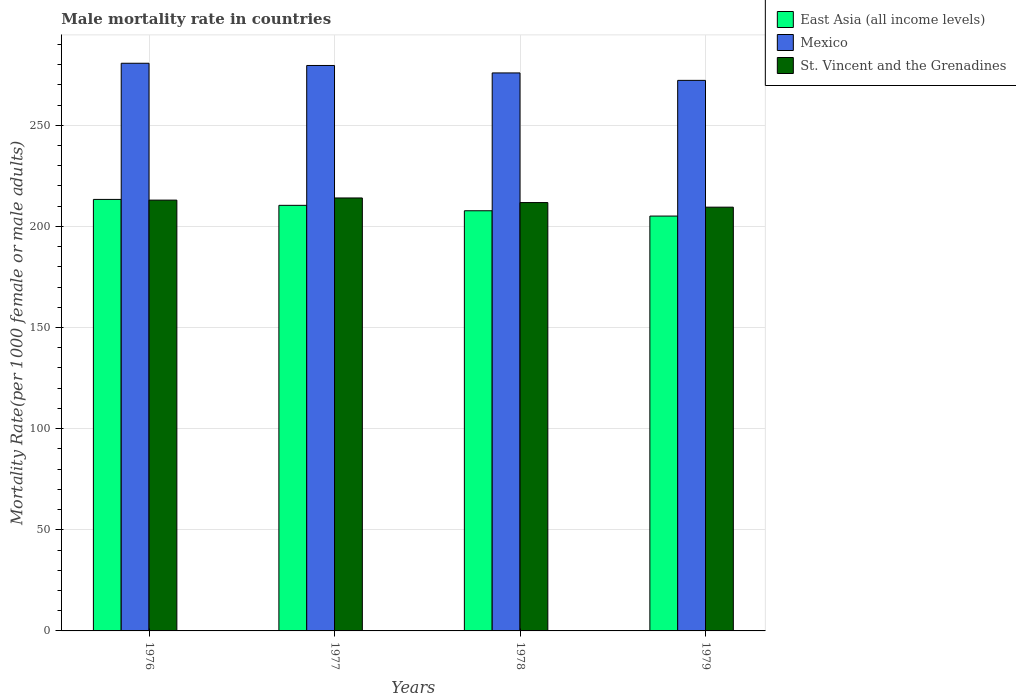How many different coloured bars are there?
Your response must be concise. 3. How many groups of bars are there?
Your answer should be very brief. 4. What is the label of the 2nd group of bars from the left?
Make the answer very short. 1977. What is the male mortality rate in St. Vincent and the Grenadines in 1976?
Ensure brevity in your answer.  212.99. Across all years, what is the maximum male mortality rate in St. Vincent and the Grenadines?
Make the answer very short. 214.05. Across all years, what is the minimum male mortality rate in East Asia (all income levels)?
Provide a short and direct response. 205.1. In which year was the male mortality rate in East Asia (all income levels) maximum?
Give a very brief answer. 1976. In which year was the male mortality rate in East Asia (all income levels) minimum?
Keep it short and to the point. 1979. What is the total male mortality rate in East Asia (all income levels) in the graph?
Provide a short and direct response. 836.56. What is the difference between the male mortality rate in St. Vincent and the Grenadines in 1977 and that in 1979?
Provide a succinct answer. 4.55. What is the difference between the male mortality rate in St. Vincent and the Grenadines in 1977 and the male mortality rate in Mexico in 1979?
Keep it short and to the point. -58.14. What is the average male mortality rate in Mexico per year?
Give a very brief answer. 277.06. In the year 1976, what is the difference between the male mortality rate in St. Vincent and the Grenadines and male mortality rate in Mexico?
Ensure brevity in your answer.  -67.66. What is the ratio of the male mortality rate in East Asia (all income levels) in 1978 to that in 1979?
Provide a short and direct response. 1.01. What is the difference between the highest and the second highest male mortality rate in St. Vincent and the Grenadines?
Offer a terse response. 1.06. What is the difference between the highest and the lowest male mortality rate in St. Vincent and the Grenadines?
Give a very brief answer. 4.55. In how many years, is the male mortality rate in St. Vincent and the Grenadines greater than the average male mortality rate in St. Vincent and the Grenadines taken over all years?
Give a very brief answer. 2. What does the 3rd bar from the right in 1978 represents?
Offer a terse response. East Asia (all income levels). How many bars are there?
Ensure brevity in your answer.  12. Are all the bars in the graph horizontal?
Your response must be concise. No. Does the graph contain any zero values?
Your answer should be very brief. No. Does the graph contain grids?
Keep it short and to the point. Yes. How are the legend labels stacked?
Offer a terse response. Vertical. What is the title of the graph?
Offer a very short reply. Male mortality rate in countries. Does "Korea (Democratic)" appear as one of the legend labels in the graph?
Your response must be concise. No. What is the label or title of the Y-axis?
Your answer should be very brief. Mortality Rate(per 1000 female or male adults). What is the Mortality Rate(per 1000 female or male adults) in East Asia (all income levels) in 1976?
Ensure brevity in your answer.  213.33. What is the Mortality Rate(per 1000 female or male adults) in Mexico in 1976?
Ensure brevity in your answer.  280.65. What is the Mortality Rate(per 1000 female or male adults) in St. Vincent and the Grenadines in 1976?
Provide a short and direct response. 212.99. What is the Mortality Rate(per 1000 female or male adults) of East Asia (all income levels) in 1977?
Offer a terse response. 210.41. What is the Mortality Rate(per 1000 female or male adults) in Mexico in 1977?
Provide a short and direct response. 279.55. What is the Mortality Rate(per 1000 female or male adults) in St. Vincent and the Grenadines in 1977?
Ensure brevity in your answer.  214.05. What is the Mortality Rate(per 1000 female or male adults) in East Asia (all income levels) in 1978?
Provide a short and direct response. 207.73. What is the Mortality Rate(per 1000 female or male adults) of Mexico in 1978?
Your answer should be very brief. 275.87. What is the Mortality Rate(per 1000 female or male adults) of St. Vincent and the Grenadines in 1978?
Your answer should be very brief. 211.78. What is the Mortality Rate(per 1000 female or male adults) of East Asia (all income levels) in 1979?
Give a very brief answer. 205.1. What is the Mortality Rate(per 1000 female or male adults) in Mexico in 1979?
Make the answer very short. 272.19. What is the Mortality Rate(per 1000 female or male adults) of St. Vincent and the Grenadines in 1979?
Keep it short and to the point. 209.5. Across all years, what is the maximum Mortality Rate(per 1000 female or male adults) of East Asia (all income levels)?
Ensure brevity in your answer.  213.33. Across all years, what is the maximum Mortality Rate(per 1000 female or male adults) in Mexico?
Keep it short and to the point. 280.65. Across all years, what is the maximum Mortality Rate(per 1000 female or male adults) in St. Vincent and the Grenadines?
Your answer should be very brief. 214.05. Across all years, what is the minimum Mortality Rate(per 1000 female or male adults) of East Asia (all income levels)?
Make the answer very short. 205.1. Across all years, what is the minimum Mortality Rate(per 1000 female or male adults) of Mexico?
Make the answer very short. 272.19. Across all years, what is the minimum Mortality Rate(per 1000 female or male adults) in St. Vincent and the Grenadines?
Your answer should be very brief. 209.5. What is the total Mortality Rate(per 1000 female or male adults) in East Asia (all income levels) in the graph?
Give a very brief answer. 836.56. What is the total Mortality Rate(per 1000 female or male adults) of Mexico in the graph?
Give a very brief answer. 1108.25. What is the total Mortality Rate(per 1000 female or male adults) in St. Vincent and the Grenadines in the graph?
Ensure brevity in your answer.  848.31. What is the difference between the Mortality Rate(per 1000 female or male adults) of East Asia (all income levels) in 1976 and that in 1977?
Offer a terse response. 2.93. What is the difference between the Mortality Rate(per 1000 female or male adults) in Mexico in 1976 and that in 1977?
Offer a very short reply. 1.1. What is the difference between the Mortality Rate(per 1000 female or male adults) in St. Vincent and the Grenadines in 1976 and that in 1977?
Ensure brevity in your answer.  -1.06. What is the difference between the Mortality Rate(per 1000 female or male adults) in East Asia (all income levels) in 1976 and that in 1978?
Make the answer very short. 5.61. What is the difference between the Mortality Rate(per 1000 female or male adults) of Mexico in 1976 and that in 1978?
Provide a short and direct response. 4.78. What is the difference between the Mortality Rate(per 1000 female or male adults) in St. Vincent and the Grenadines in 1976 and that in 1978?
Provide a succinct answer. 1.21. What is the difference between the Mortality Rate(per 1000 female or male adults) in East Asia (all income levels) in 1976 and that in 1979?
Provide a succinct answer. 8.24. What is the difference between the Mortality Rate(per 1000 female or male adults) in Mexico in 1976 and that in 1979?
Offer a very short reply. 8.46. What is the difference between the Mortality Rate(per 1000 female or male adults) of St. Vincent and the Grenadines in 1976 and that in 1979?
Provide a short and direct response. 3.48. What is the difference between the Mortality Rate(per 1000 female or male adults) in East Asia (all income levels) in 1977 and that in 1978?
Provide a short and direct response. 2.68. What is the difference between the Mortality Rate(per 1000 female or male adults) in Mexico in 1977 and that in 1978?
Offer a terse response. 3.68. What is the difference between the Mortality Rate(per 1000 female or male adults) in St. Vincent and the Grenadines in 1977 and that in 1978?
Ensure brevity in your answer.  2.27. What is the difference between the Mortality Rate(per 1000 female or male adults) in East Asia (all income levels) in 1977 and that in 1979?
Offer a terse response. 5.31. What is the difference between the Mortality Rate(per 1000 female or male adults) in Mexico in 1977 and that in 1979?
Your answer should be very brief. 7.36. What is the difference between the Mortality Rate(per 1000 female or male adults) of St. Vincent and the Grenadines in 1977 and that in 1979?
Ensure brevity in your answer.  4.55. What is the difference between the Mortality Rate(per 1000 female or male adults) in East Asia (all income levels) in 1978 and that in 1979?
Keep it short and to the point. 2.63. What is the difference between the Mortality Rate(per 1000 female or male adults) of Mexico in 1978 and that in 1979?
Keep it short and to the point. 3.68. What is the difference between the Mortality Rate(per 1000 female or male adults) in St. Vincent and the Grenadines in 1978 and that in 1979?
Ensure brevity in your answer.  2.27. What is the difference between the Mortality Rate(per 1000 female or male adults) of East Asia (all income levels) in 1976 and the Mortality Rate(per 1000 female or male adults) of Mexico in 1977?
Your answer should be compact. -66.21. What is the difference between the Mortality Rate(per 1000 female or male adults) of East Asia (all income levels) in 1976 and the Mortality Rate(per 1000 female or male adults) of St. Vincent and the Grenadines in 1977?
Give a very brief answer. -0.72. What is the difference between the Mortality Rate(per 1000 female or male adults) of Mexico in 1976 and the Mortality Rate(per 1000 female or male adults) of St. Vincent and the Grenadines in 1977?
Keep it short and to the point. 66.6. What is the difference between the Mortality Rate(per 1000 female or male adults) of East Asia (all income levels) in 1976 and the Mortality Rate(per 1000 female or male adults) of Mexico in 1978?
Provide a succinct answer. -62.54. What is the difference between the Mortality Rate(per 1000 female or male adults) in East Asia (all income levels) in 1976 and the Mortality Rate(per 1000 female or male adults) in St. Vincent and the Grenadines in 1978?
Provide a short and direct response. 1.56. What is the difference between the Mortality Rate(per 1000 female or male adults) of Mexico in 1976 and the Mortality Rate(per 1000 female or male adults) of St. Vincent and the Grenadines in 1978?
Your answer should be very brief. 68.87. What is the difference between the Mortality Rate(per 1000 female or male adults) of East Asia (all income levels) in 1976 and the Mortality Rate(per 1000 female or male adults) of Mexico in 1979?
Give a very brief answer. -58.86. What is the difference between the Mortality Rate(per 1000 female or male adults) of East Asia (all income levels) in 1976 and the Mortality Rate(per 1000 female or male adults) of St. Vincent and the Grenadines in 1979?
Provide a short and direct response. 3.83. What is the difference between the Mortality Rate(per 1000 female or male adults) of Mexico in 1976 and the Mortality Rate(per 1000 female or male adults) of St. Vincent and the Grenadines in 1979?
Keep it short and to the point. 71.15. What is the difference between the Mortality Rate(per 1000 female or male adults) of East Asia (all income levels) in 1977 and the Mortality Rate(per 1000 female or male adults) of Mexico in 1978?
Your answer should be very brief. -65.46. What is the difference between the Mortality Rate(per 1000 female or male adults) of East Asia (all income levels) in 1977 and the Mortality Rate(per 1000 female or male adults) of St. Vincent and the Grenadines in 1978?
Offer a very short reply. -1.37. What is the difference between the Mortality Rate(per 1000 female or male adults) in Mexico in 1977 and the Mortality Rate(per 1000 female or male adults) in St. Vincent and the Grenadines in 1978?
Give a very brief answer. 67.77. What is the difference between the Mortality Rate(per 1000 female or male adults) in East Asia (all income levels) in 1977 and the Mortality Rate(per 1000 female or male adults) in Mexico in 1979?
Your answer should be compact. -61.78. What is the difference between the Mortality Rate(per 1000 female or male adults) in East Asia (all income levels) in 1977 and the Mortality Rate(per 1000 female or male adults) in St. Vincent and the Grenadines in 1979?
Give a very brief answer. 0.91. What is the difference between the Mortality Rate(per 1000 female or male adults) of Mexico in 1977 and the Mortality Rate(per 1000 female or male adults) of St. Vincent and the Grenadines in 1979?
Make the answer very short. 70.05. What is the difference between the Mortality Rate(per 1000 female or male adults) in East Asia (all income levels) in 1978 and the Mortality Rate(per 1000 female or male adults) in Mexico in 1979?
Provide a succinct answer. -64.46. What is the difference between the Mortality Rate(per 1000 female or male adults) in East Asia (all income levels) in 1978 and the Mortality Rate(per 1000 female or male adults) in St. Vincent and the Grenadines in 1979?
Make the answer very short. -1.77. What is the difference between the Mortality Rate(per 1000 female or male adults) of Mexico in 1978 and the Mortality Rate(per 1000 female or male adults) of St. Vincent and the Grenadines in 1979?
Make the answer very short. 66.37. What is the average Mortality Rate(per 1000 female or male adults) of East Asia (all income levels) per year?
Your answer should be very brief. 209.14. What is the average Mortality Rate(per 1000 female or male adults) in Mexico per year?
Provide a succinct answer. 277.06. What is the average Mortality Rate(per 1000 female or male adults) of St. Vincent and the Grenadines per year?
Give a very brief answer. 212.08. In the year 1976, what is the difference between the Mortality Rate(per 1000 female or male adults) of East Asia (all income levels) and Mortality Rate(per 1000 female or male adults) of Mexico?
Offer a terse response. -67.31. In the year 1976, what is the difference between the Mortality Rate(per 1000 female or male adults) in East Asia (all income levels) and Mortality Rate(per 1000 female or male adults) in St. Vincent and the Grenadines?
Your answer should be very brief. 0.35. In the year 1976, what is the difference between the Mortality Rate(per 1000 female or male adults) in Mexico and Mortality Rate(per 1000 female or male adults) in St. Vincent and the Grenadines?
Provide a short and direct response. 67.66. In the year 1977, what is the difference between the Mortality Rate(per 1000 female or male adults) of East Asia (all income levels) and Mortality Rate(per 1000 female or male adults) of Mexico?
Ensure brevity in your answer.  -69.14. In the year 1977, what is the difference between the Mortality Rate(per 1000 female or male adults) in East Asia (all income levels) and Mortality Rate(per 1000 female or male adults) in St. Vincent and the Grenadines?
Your response must be concise. -3.64. In the year 1977, what is the difference between the Mortality Rate(per 1000 female or male adults) in Mexico and Mortality Rate(per 1000 female or male adults) in St. Vincent and the Grenadines?
Keep it short and to the point. 65.5. In the year 1978, what is the difference between the Mortality Rate(per 1000 female or male adults) of East Asia (all income levels) and Mortality Rate(per 1000 female or male adults) of Mexico?
Keep it short and to the point. -68.14. In the year 1978, what is the difference between the Mortality Rate(per 1000 female or male adults) in East Asia (all income levels) and Mortality Rate(per 1000 female or male adults) in St. Vincent and the Grenadines?
Your answer should be very brief. -4.05. In the year 1978, what is the difference between the Mortality Rate(per 1000 female or male adults) in Mexico and Mortality Rate(per 1000 female or male adults) in St. Vincent and the Grenadines?
Ensure brevity in your answer.  64.09. In the year 1979, what is the difference between the Mortality Rate(per 1000 female or male adults) in East Asia (all income levels) and Mortality Rate(per 1000 female or male adults) in Mexico?
Ensure brevity in your answer.  -67.1. In the year 1979, what is the difference between the Mortality Rate(per 1000 female or male adults) of East Asia (all income levels) and Mortality Rate(per 1000 female or male adults) of St. Vincent and the Grenadines?
Your answer should be compact. -4.41. In the year 1979, what is the difference between the Mortality Rate(per 1000 female or male adults) in Mexico and Mortality Rate(per 1000 female or male adults) in St. Vincent and the Grenadines?
Your answer should be very brief. 62.69. What is the ratio of the Mortality Rate(per 1000 female or male adults) of East Asia (all income levels) in 1976 to that in 1977?
Provide a succinct answer. 1.01. What is the ratio of the Mortality Rate(per 1000 female or male adults) of Mexico in 1976 to that in 1977?
Your response must be concise. 1. What is the ratio of the Mortality Rate(per 1000 female or male adults) in St. Vincent and the Grenadines in 1976 to that in 1977?
Your answer should be compact. 0.99. What is the ratio of the Mortality Rate(per 1000 female or male adults) of East Asia (all income levels) in 1976 to that in 1978?
Offer a terse response. 1.03. What is the ratio of the Mortality Rate(per 1000 female or male adults) in Mexico in 1976 to that in 1978?
Your answer should be compact. 1.02. What is the ratio of the Mortality Rate(per 1000 female or male adults) in St. Vincent and the Grenadines in 1976 to that in 1978?
Provide a short and direct response. 1.01. What is the ratio of the Mortality Rate(per 1000 female or male adults) of East Asia (all income levels) in 1976 to that in 1979?
Offer a terse response. 1.04. What is the ratio of the Mortality Rate(per 1000 female or male adults) of Mexico in 1976 to that in 1979?
Ensure brevity in your answer.  1.03. What is the ratio of the Mortality Rate(per 1000 female or male adults) in St. Vincent and the Grenadines in 1976 to that in 1979?
Provide a succinct answer. 1.02. What is the ratio of the Mortality Rate(per 1000 female or male adults) in East Asia (all income levels) in 1977 to that in 1978?
Ensure brevity in your answer.  1.01. What is the ratio of the Mortality Rate(per 1000 female or male adults) of Mexico in 1977 to that in 1978?
Your answer should be compact. 1.01. What is the ratio of the Mortality Rate(per 1000 female or male adults) of St. Vincent and the Grenadines in 1977 to that in 1978?
Provide a short and direct response. 1.01. What is the ratio of the Mortality Rate(per 1000 female or male adults) of East Asia (all income levels) in 1977 to that in 1979?
Give a very brief answer. 1.03. What is the ratio of the Mortality Rate(per 1000 female or male adults) in St. Vincent and the Grenadines in 1977 to that in 1979?
Provide a succinct answer. 1.02. What is the ratio of the Mortality Rate(per 1000 female or male adults) in East Asia (all income levels) in 1978 to that in 1979?
Provide a short and direct response. 1.01. What is the ratio of the Mortality Rate(per 1000 female or male adults) in Mexico in 1978 to that in 1979?
Your answer should be compact. 1.01. What is the ratio of the Mortality Rate(per 1000 female or male adults) of St. Vincent and the Grenadines in 1978 to that in 1979?
Your response must be concise. 1.01. What is the difference between the highest and the second highest Mortality Rate(per 1000 female or male adults) of East Asia (all income levels)?
Give a very brief answer. 2.93. What is the difference between the highest and the second highest Mortality Rate(per 1000 female or male adults) of Mexico?
Provide a short and direct response. 1.1. What is the difference between the highest and the second highest Mortality Rate(per 1000 female or male adults) in St. Vincent and the Grenadines?
Keep it short and to the point. 1.06. What is the difference between the highest and the lowest Mortality Rate(per 1000 female or male adults) of East Asia (all income levels)?
Ensure brevity in your answer.  8.24. What is the difference between the highest and the lowest Mortality Rate(per 1000 female or male adults) in Mexico?
Your answer should be compact. 8.46. What is the difference between the highest and the lowest Mortality Rate(per 1000 female or male adults) in St. Vincent and the Grenadines?
Ensure brevity in your answer.  4.55. 